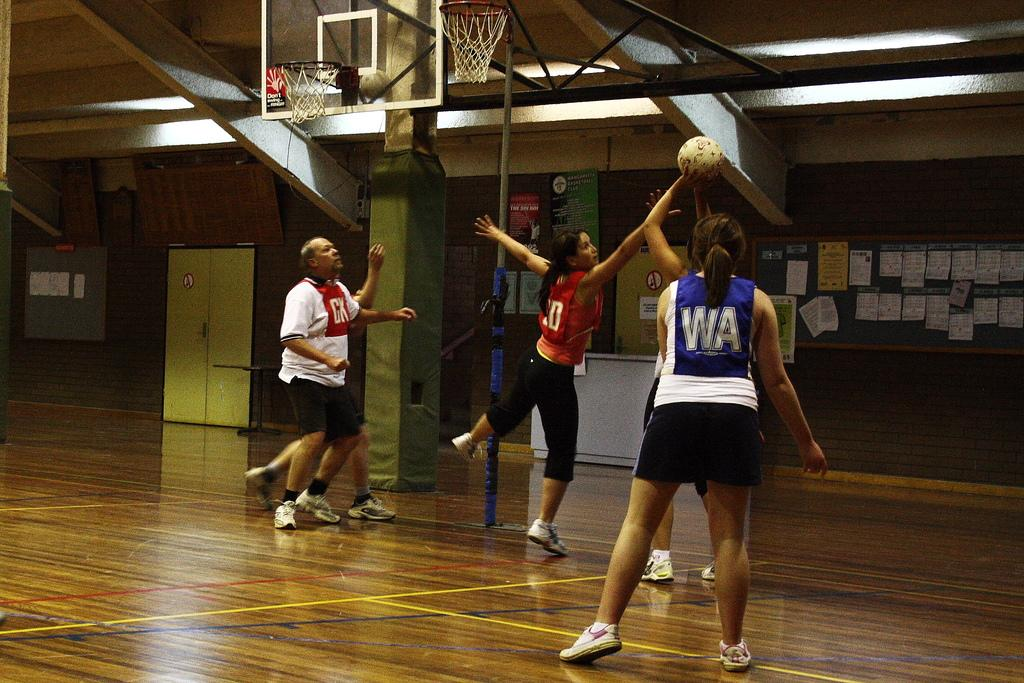<image>
Share a concise interpretation of the image provided. A person playing basketball is wearing a WA jersey. 